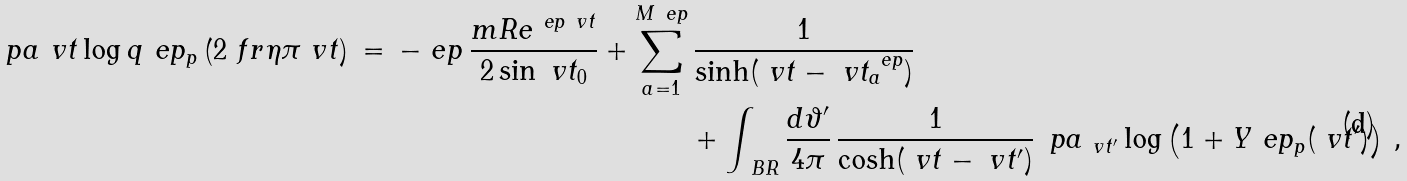Convert formula to latex. <formula><loc_0><loc_0><loc_500><loc_500>\ p a _ { \ } v t \log q ^ { \ } e p _ { p } \left ( 2 \ f r { \eta } { \pi } \ v t \right ) \, = \, - \ e p \, \frac { m R e ^ { \ e p \ v t } } { 2 \sin \ v t _ { 0 } } + \sum _ { a = 1 } ^ { M ^ { \ } e p } & \, \frac { 1 } { \sinh ( \ v t - \ v t ^ { \ e p } _ { a } ) } \\ & + \int _ { \ B R } \frac { d \vartheta ^ { \prime } } { 4 \pi } \, \frac { 1 } { \cosh ( \ v t - \ v t ^ { \prime } ) } \, \ p a _ { \ v t ^ { \prime } } \log \left ( 1 + Y ^ { \ } e p _ { p } ( \ v t ^ { \prime } ) \right ) \, ,</formula> 